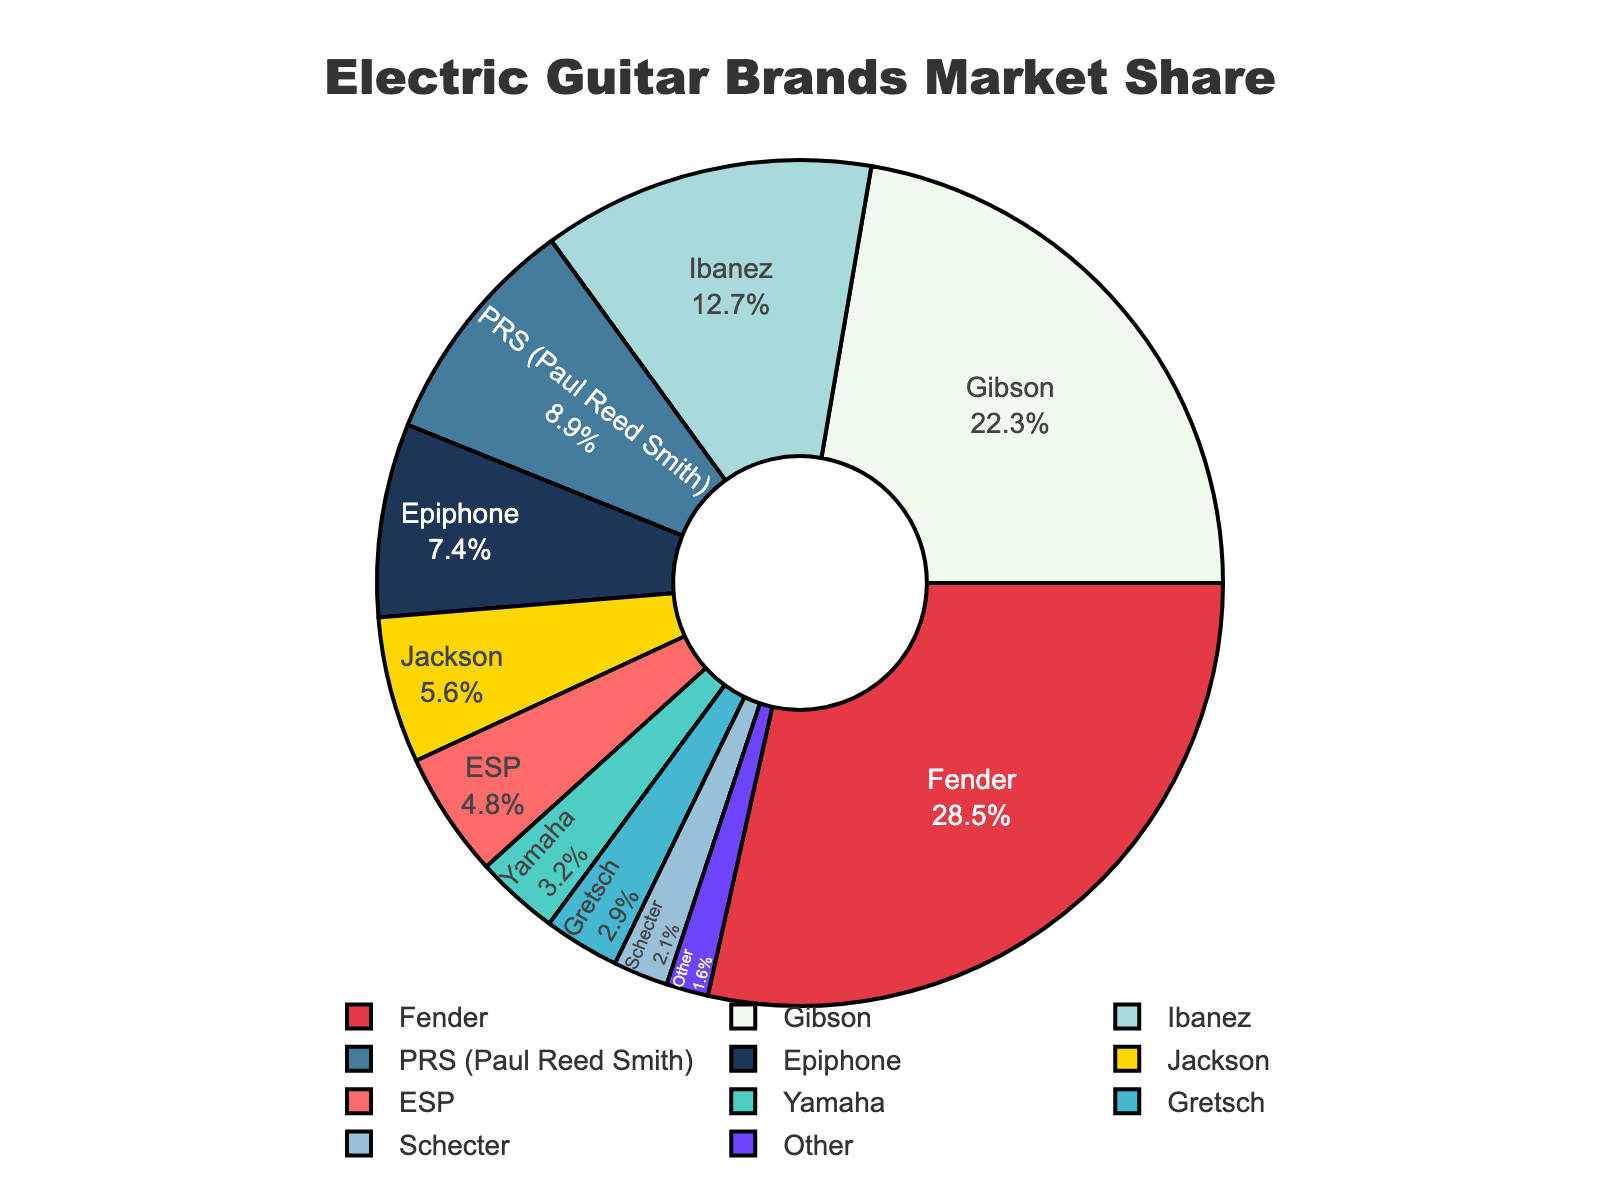What is the most popular electric guitar brand based on market share? The pie chart shows different sections representing various electric guitar brands, with each section's size corresponding to its market share. The largest section indicates the highest market share. For this chart, the largest section is labeled Fender with a market share of 28.5%.
Answer: Fender Which two brands combined have a market share above 50%? By checking the market share of each brand in the pie chart and summing the top two brands, we see that Fender (28.5%) and Gibson (22.3%) together have a combined market share of 28.5 + 22.3 = 50.8%, which is above 50%.
Answer: Fender and Gibson Which brand has a market share closest to 7%? The pie chart labels each section with the brand and its market share. The label closest to 7% is Epiphone with a market share of 7.4%.
Answer: Epiphone What is the combined market share of Ibanez, PRS, and Epiphone? From the pie chart, we need to add the market shares of Ibanez (12.7%), PRS (8.9%), and Epiphone (7.4%). The combined market share is 12.7 + 8.9 + 7.4 = 29%.
Answer: 29% Which brand has the smallest market share and what is it? The smallest section in the pie chart represents the brand with the lowest market share. This section is labeled "Other" with a market share of 1.6%.
Answer: Other, 1.6% How much larger is Fender's market share compared to Yamaha's? The market shares of Fender and Yamaha can be found on the pie chart. Fender has a 28.5% market share, and Yamaha has a 3.2% market share. The difference is 28.5 - 3.2 = 25.3%.
Answer: 25.3% Which brands have a market share greater than 10%? By observing the pie chart, we identify brands with market shares labeled above 10%. These brands are Fender (28.5%), Gibson (22.3%), and Ibanez (12.7%).
Answer: Fender, Gibson, and Ibanez 